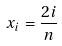<formula> <loc_0><loc_0><loc_500><loc_500>x _ { i } = \frac { 2 i } { n }</formula> 